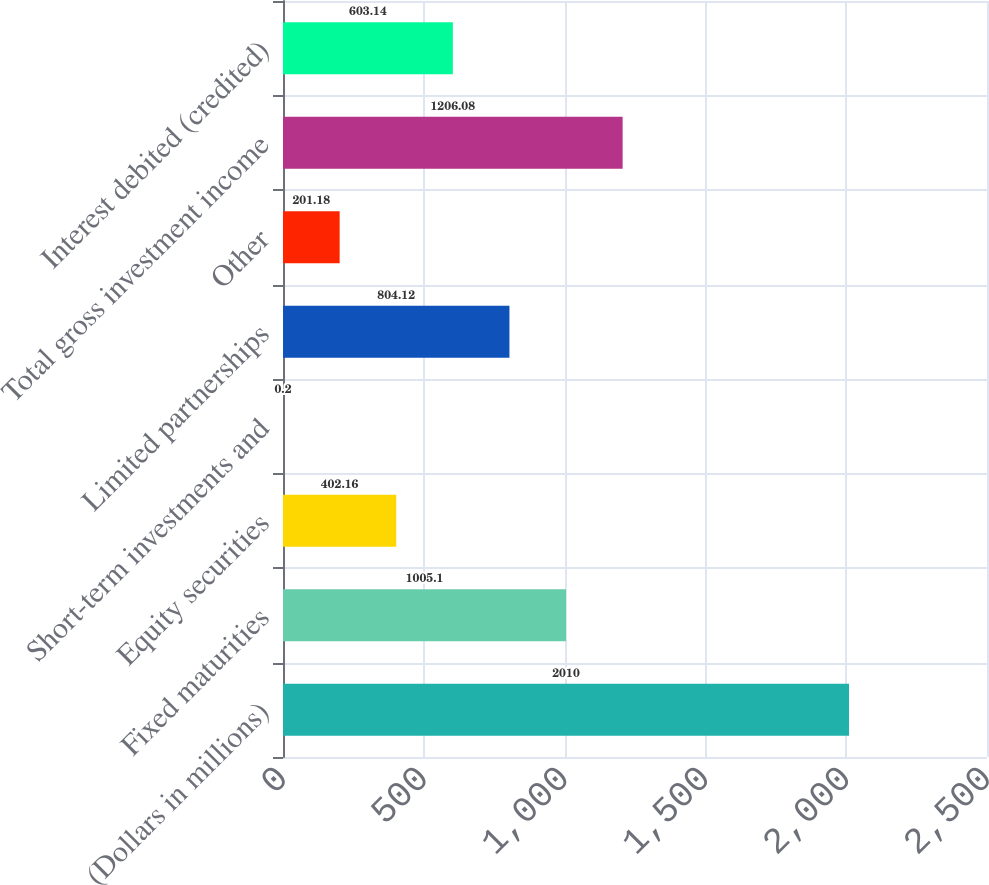Convert chart to OTSL. <chart><loc_0><loc_0><loc_500><loc_500><bar_chart><fcel>(Dollars in millions)<fcel>Fixed maturities<fcel>Equity securities<fcel>Short-term investments and<fcel>Limited partnerships<fcel>Other<fcel>Total gross investment income<fcel>Interest debited (credited)<nl><fcel>2010<fcel>1005.1<fcel>402.16<fcel>0.2<fcel>804.12<fcel>201.18<fcel>1206.08<fcel>603.14<nl></chart> 